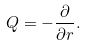Convert formula to latex. <formula><loc_0><loc_0><loc_500><loc_500>Q = - \frac { \partial } { \partial r } .</formula> 